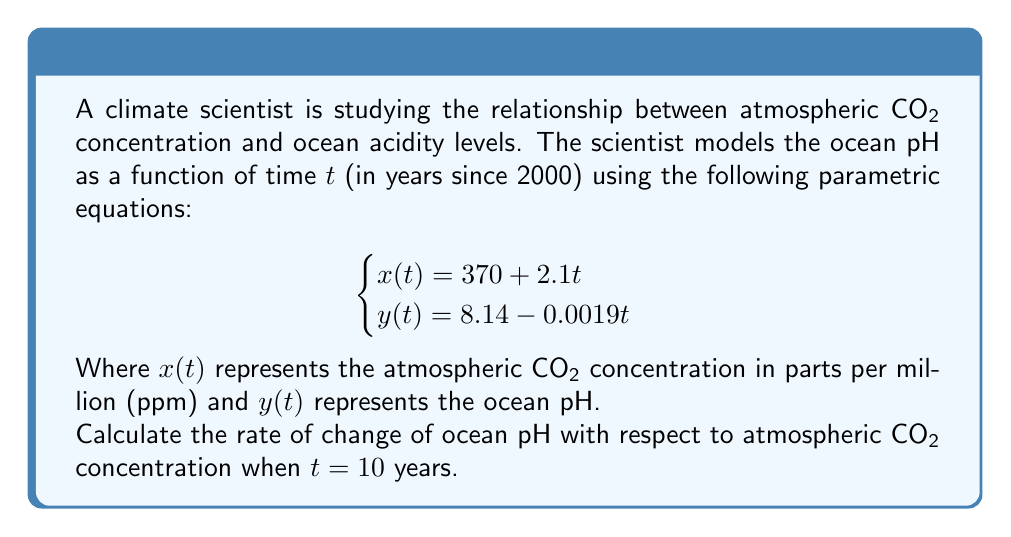Provide a solution to this math problem. To solve this problem, we need to follow these steps:

1) First, we need to find dy/dx. Since both x and y are functions of t, we can use the chain rule:

   $$\frac{dy}{dx} = \frac{dy/dt}{dx/dt}$$

2) From the given equations:
   $$\frac{dx}{dt} = 2.1$$
   $$\frac{dy}{dt} = -0.0019$$

3) Substituting these into our chain rule equation:

   $$\frac{dy}{dx} = \frac{-0.0019}{2.1}$$

4) Simplifying:

   $$\frac{dy}{dx} = -0.0009047619$$

5) This rate is constant for all values of t, so it's the same at t = 10 years.

6) To interpret this result: For every 1 ppm increase in atmospheric CO₂, the ocean pH decreases by approximately 0.0009047619 units.
Answer: $-0.0009047619$ pH units per ppm CO₂ 